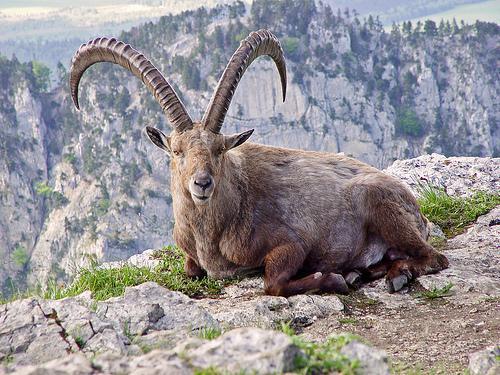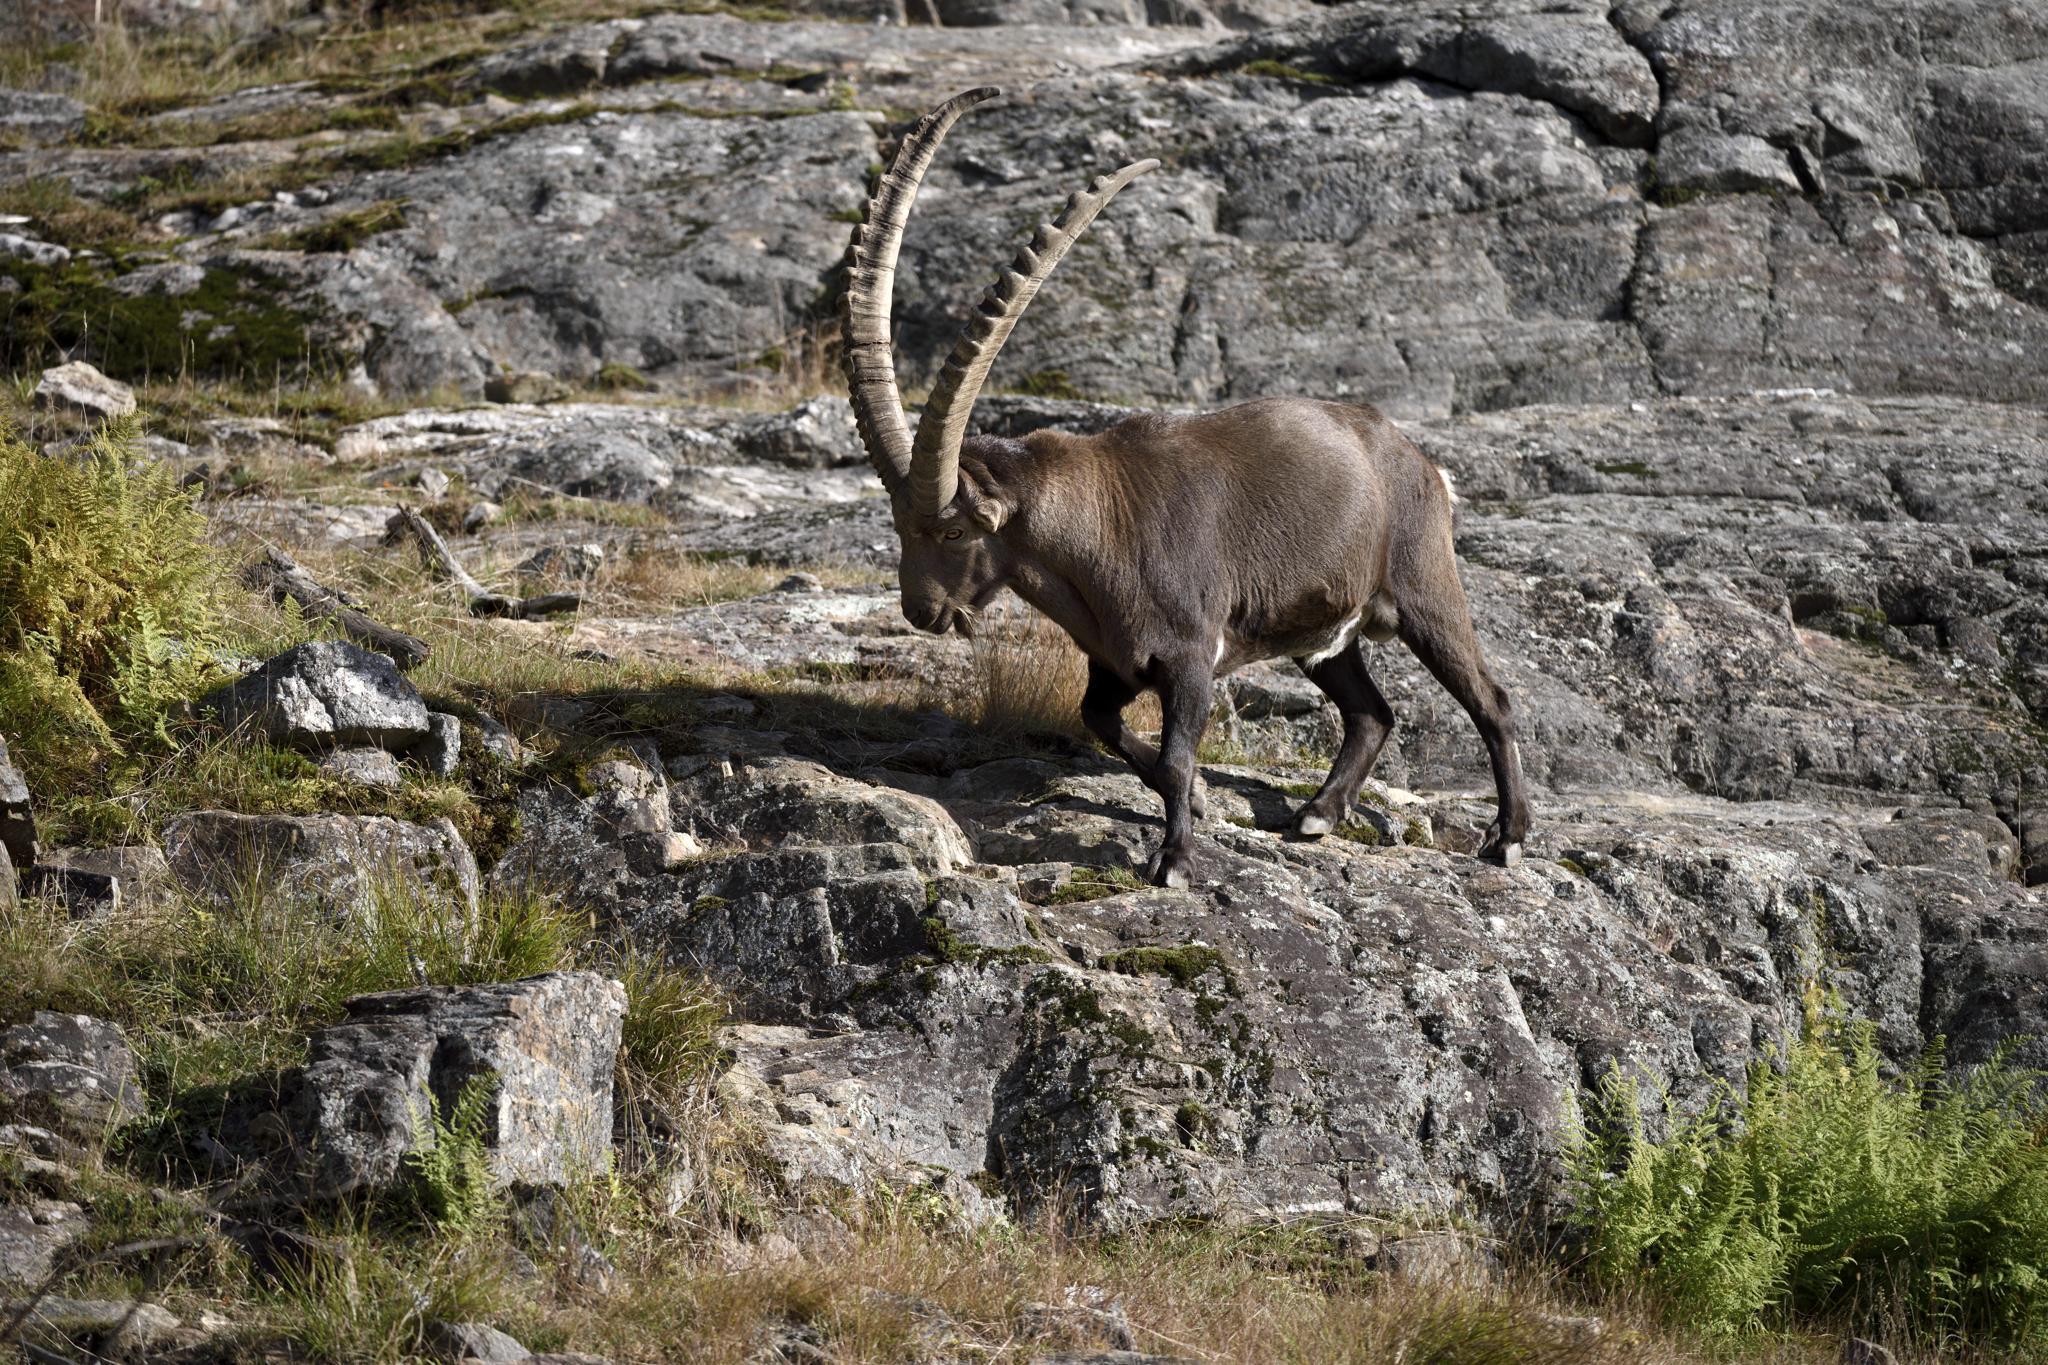The first image is the image on the left, the second image is the image on the right. Analyze the images presented: Is the assertion "both animals are facing the same direction." valid? Answer yes or no. Yes. 